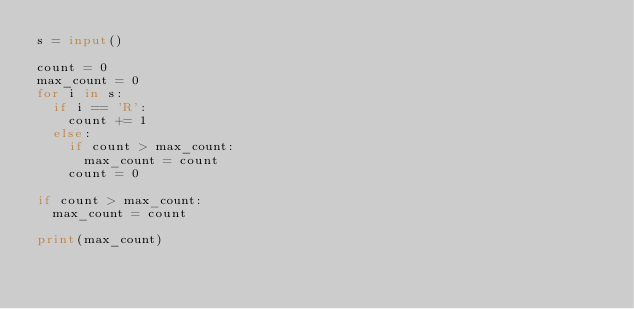Convert code to text. <code><loc_0><loc_0><loc_500><loc_500><_Python_>s = input()

count = 0
max_count = 0
for i in s:
  if i == 'R':
    count += 1
  else:
    if count > max_count:
      max_count = count
    count = 0
    
if count > max_count:
  max_count = count

print(max_count)</code> 